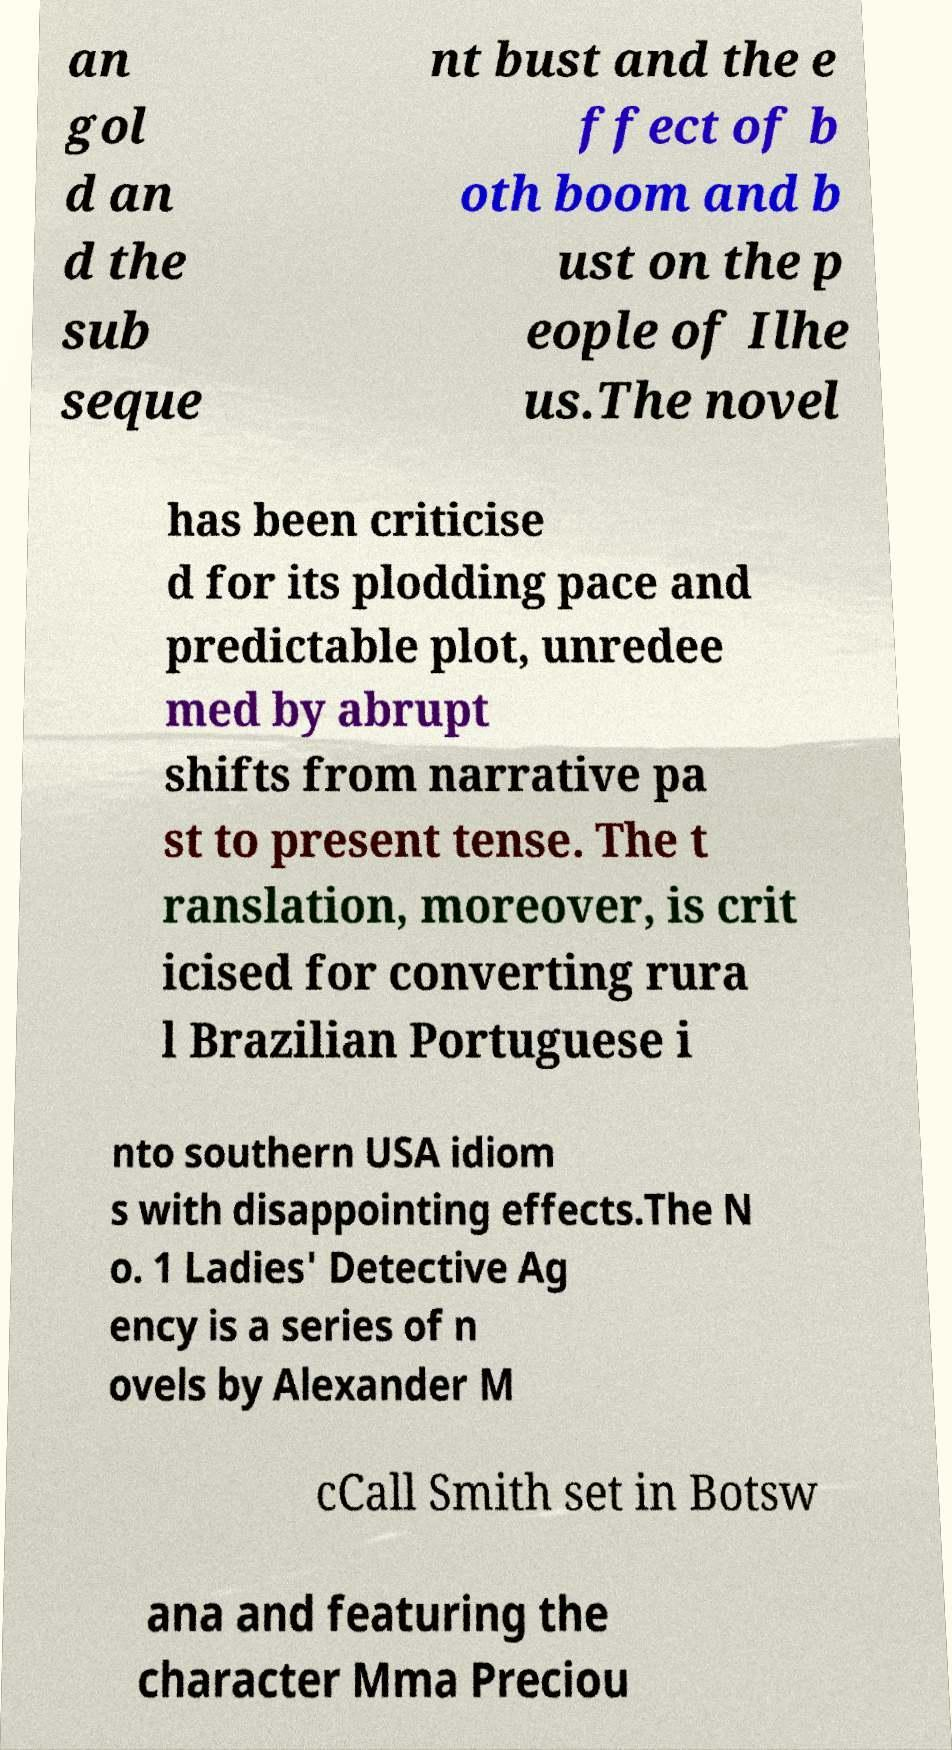There's text embedded in this image that I need extracted. Can you transcribe it verbatim? an gol d an d the sub seque nt bust and the e ffect of b oth boom and b ust on the p eople of Ilhe us.The novel has been criticise d for its plodding pace and predictable plot, unredee med by abrupt shifts from narrative pa st to present tense. The t ranslation, moreover, is crit icised for converting rura l Brazilian Portuguese i nto southern USA idiom s with disappointing effects.The N o. 1 Ladies' Detective Ag ency is a series of n ovels by Alexander M cCall Smith set in Botsw ana and featuring the character Mma Preciou 